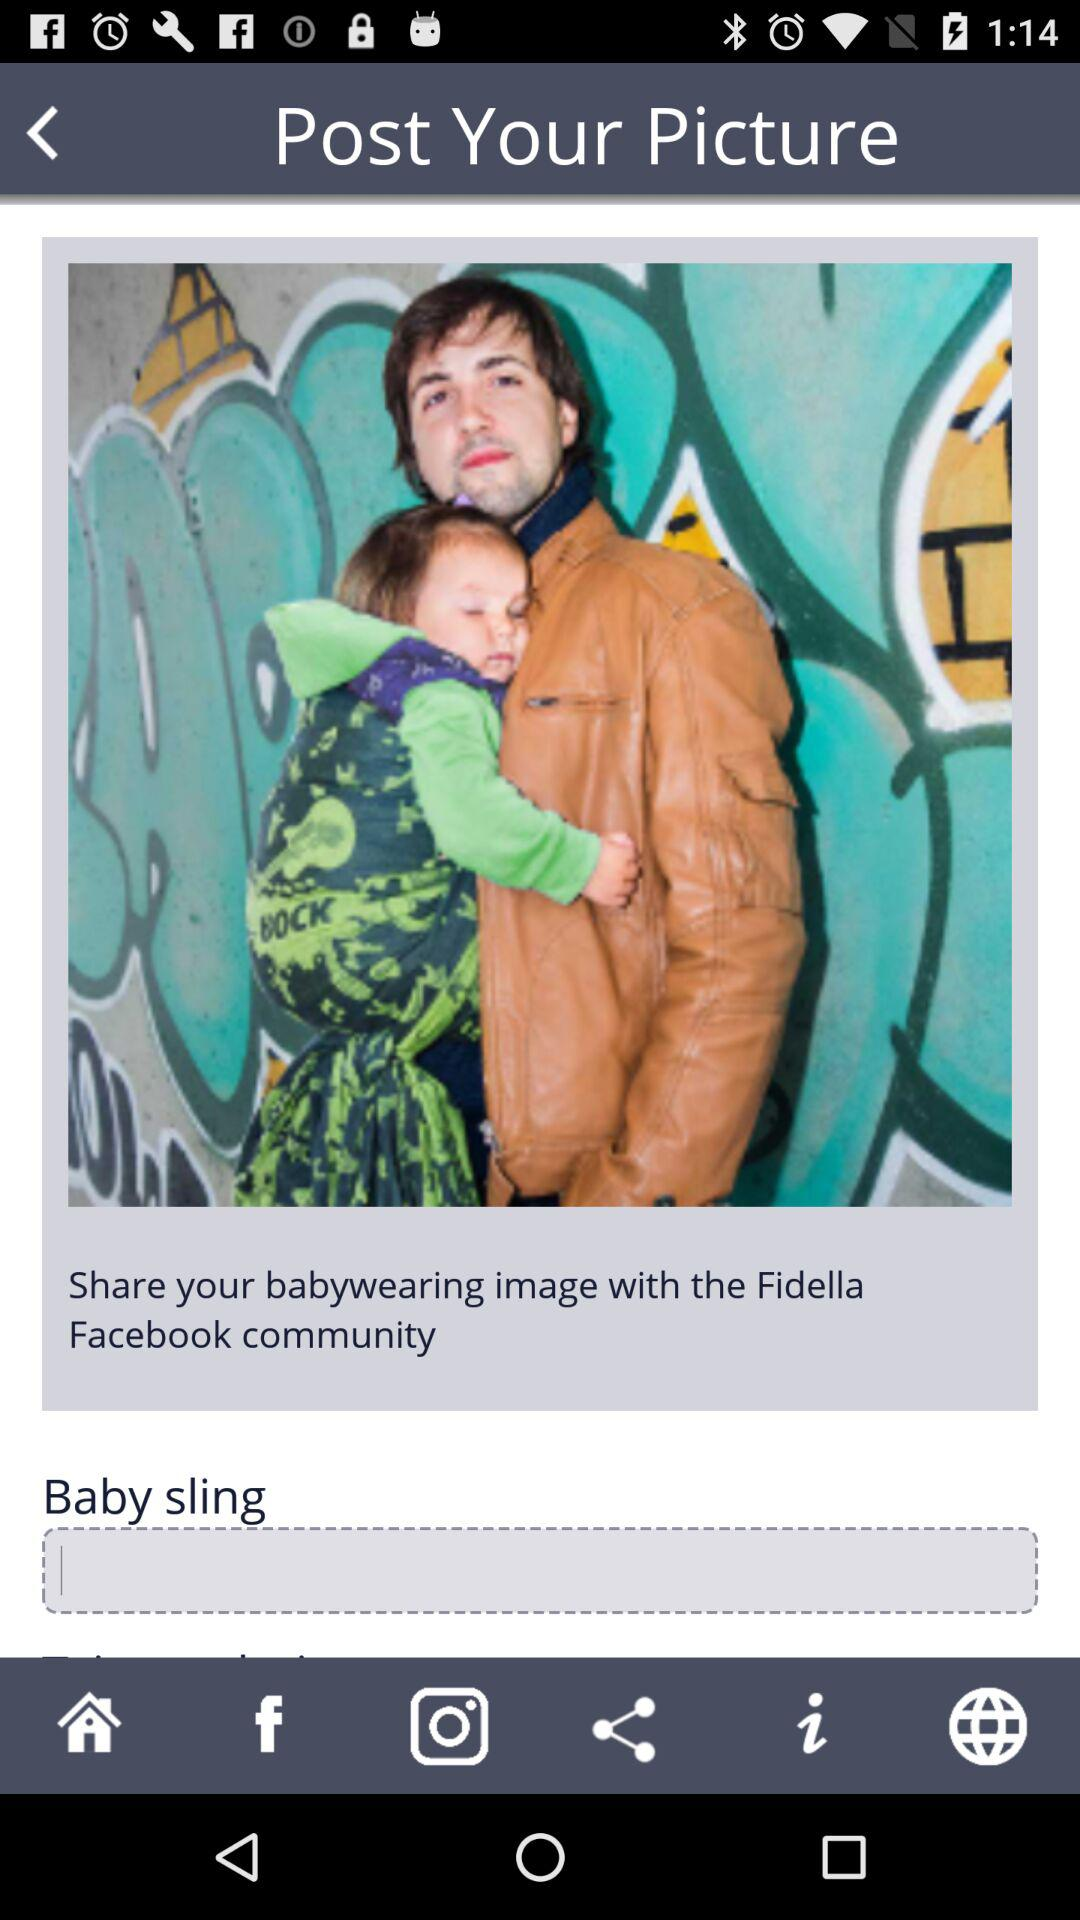On which social media sites can we share the image? You can share the image on "Facebook" and "Instagram". 